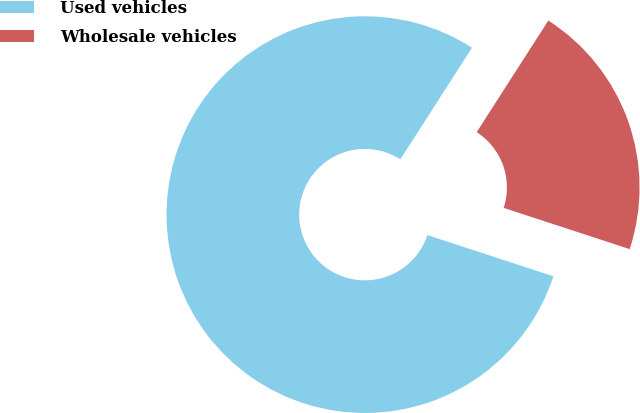Convert chart to OTSL. <chart><loc_0><loc_0><loc_500><loc_500><pie_chart><fcel>Used vehicles<fcel>Wholesale vehicles<nl><fcel>79.05%<fcel>20.95%<nl></chart> 